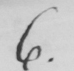Can you read and transcribe this handwriting? 6 . 